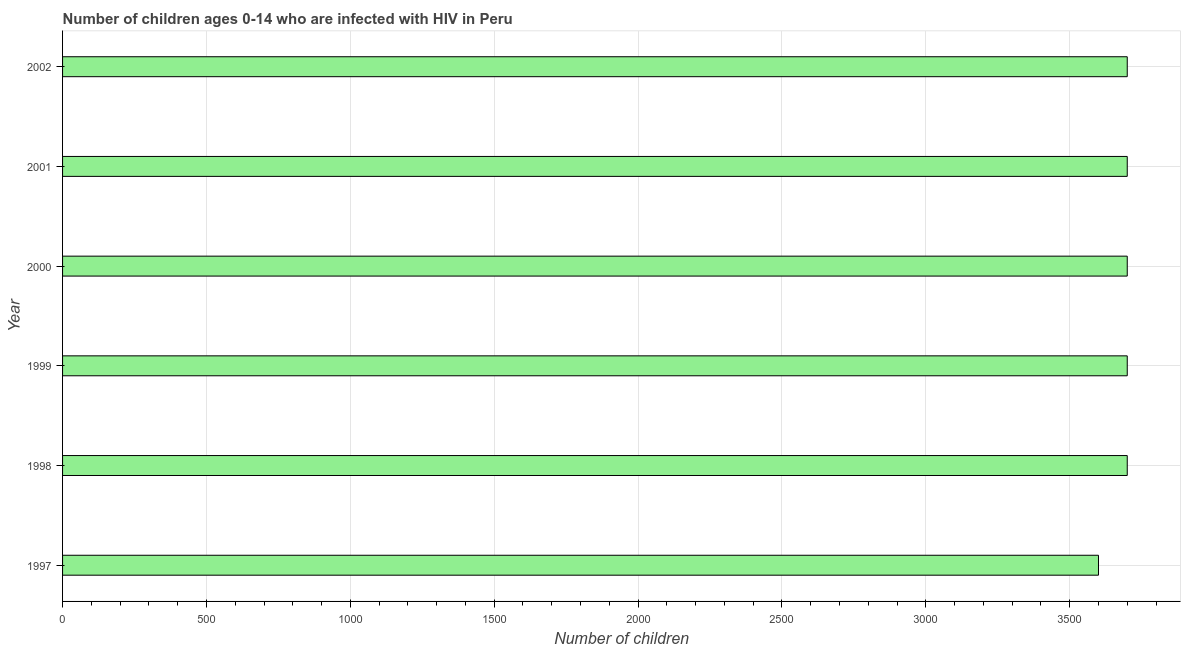Does the graph contain any zero values?
Your answer should be very brief. No. Does the graph contain grids?
Your response must be concise. Yes. What is the title of the graph?
Keep it short and to the point. Number of children ages 0-14 who are infected with HIV in Peru. What is the label or title of the X-axis?
Provide a succinct answer. Number of children. What is the number of children living with hiv in 2000?
Keep it short and to the point. 3700. Across all years, what is the maximum number of children living with hiv?
Your answer should be compact. 3700. Across all years, what is the minimum number of children living with hiv?
Offer a very short reply. 3600. In which year was the number of children living with hiv minimum?
Keep it short and to the point. 1997. What is the sum of the number of children living with hiv?
Offer a terse response. 2.21e+04. What is the difference between the number of children living with hiv in 1998 and 1999?
Your answer should be compact. 0. What is the average number of children living with hiv per year?
Your response must be concise. 3683. What is the median number of children living with hiv?
Your response must be concise. 3700. In how many years, is the number of children living with hiv greater than 100 ?
Your response must be concise. 6. Do a majority of the years between 2000 and 2001 (inclusive) have number of children living with hiv greater than 700 ?
Provide a succinct answer. Yes. What is the ratio of the number of children living with hiv in 1998 to that in 2002?
Provide a short and direct response. 1. Is the sum of the number of children living with hiv in 1997 and 1999 greater than the maximum number of children living with hiv across all years?
Provide a succinct answer. Yes. What is the difference between the highest and the lowest number of children living with hiv?
Your response must be concise. 100. In how many years, is the number of children living with hiv greater than the average number of children living with hiv taken over all years?
Ensure brevity in your answer.  5. Are all the bars in the graph horizontal?
Give a very brief answer. Yes. Are the values on the major ticks of X-axis written in scientific E-notation?
Ensure brevity in your answer.  No. What is the Number of children of 1997?
Your answer should be compact. 3600. What is the Number of children in 1998?
Provide a succinct answer. 3700. What is the Number of children of 1999?
Keep it short and to the point. 3700. What is the Number of children of 2000?
Your response must be concise. 3700. What is the Number of children of 2001?
Keep it short and to the point. 3700. What is the Number of children in 2002?
Your response must be concise. 3700. What is the difference between the Number of children in 1997 and 1998?
Offer a very short reply. -100. What is the difference between the Number of children in 1997 and 1999?
Ensure brevity in your answer.  -100. What is the difference between the Number of children in 1997 and 2000?
Provide a short and direct response. -100. What is the difference between the Number of children in 1997 and 2001?
Provide a short and direct response. -100. What is the difference between the Number of children in 1997 and 2002?
Provide a short and direct response. -100. What is the difference between the Number of children in 1998 and 2000?
Offer a terse response. 0. What is the difference between the Number of children in 1999 and 2002?
Offer a very short reply. 0. What is the difference between the Number of children in 2000 and 2002?
Ensure brevity in your answer.  0. What is the difference between the Number of children in 2001 and 2002?
Provide a short and direct response. 0. What is the ratio of the Number of children in 1997 to that in 1999?
Ensure brevity in your answer.  0.97. What is the ratio of the Number of children in 1997 to that in 2000?
Offer a terse response. 0.97. What is the ratio of the Number of children in 1997 to that in 2001?
Ensure brevity in your answer.  0.97. What is the ratio of the Number of children in 1997 to that in 2002?
Offer a terse response. 0.97. What is the ratio of the Number of children in 1998 to that in 1999?
Offer a very short reply. 1. What is the ratio of the Number of children in 1998 to that in 2001?
Make the answer very short. 1. What is the ratio of the Number of children in 1999 to that in 2000?
Your answer should be compact. 1. What is the ratio of the Number of children in 1999 to that in 2001?
Your answer should be compact. 1. What is the ratio of the Number of children in 1999 to that in 2002?
Your answer should be compact. 1. What is the ratio of the Number of children in 2000 to that in 2001?
Make the answer very short. 1. What is the ratio of the Number of children in 2000 to that in 2002?
Your answer should be very brief. 1. 